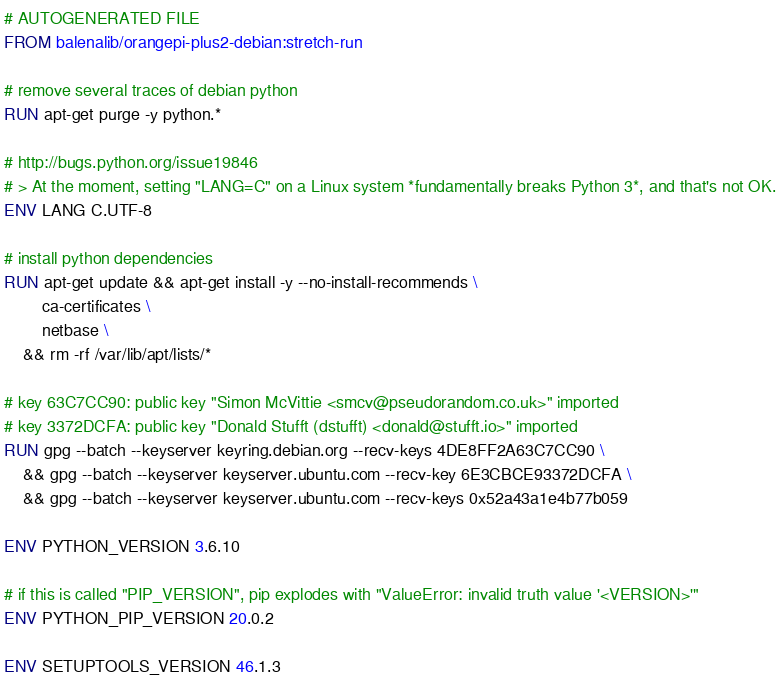Convert code to text. <code><loc_0><loc_0><loc_500><loc_500><_Dockerfile_># AUTOGENERATED FILE
FROM balenalib/orangepi-plus2-debian:stretch-run

# remove several traces of debian python
RUN apt-get purge -y python.*

# http://bugs.python.org/issue19846
# > At the moment, setting "LANG=C" on a Linux system *fundamentally breaks Python 3*, and that's not OK.
ENV LANG C.UTF-8

# install python dependencies
RUN apt-get update && apt-get install -y --no-install-recommends \
		ca-certificates \
		netbase \
	&& rm -rf /var/lib/apt/lists/*

# key 63C7CC90: public key "Simon McVittie <smcv@pseudorandom.co.uk>" imported
# key 3372DCFA: public key "Donald Stufft (dstufft) <donald@stufft.io>" imported
RUN gpg --batch --keyserver keyring.debian.org --recv-keys 4DE8FF2A63C7CC90 \
	&& gpg --batch --keyserver keyserver.ubuntu.com --recv-key 6E3CBCE93372DCFA \
	&& gpg --batch --keyserver keyserver.ubuntu.com --recv-keys 0x52a43a1e4b77b059

ENV PYTHON_VERSION 3.6.10

# if this is called "PIP_VERSION", pip explodes with "ValueError: invalid truth value '<VERSION>'"
ENV PYTHON_PIP_VERSION 20.0.2

ENV SETUPTOOLS_VERSION 46.1.3
</code> 